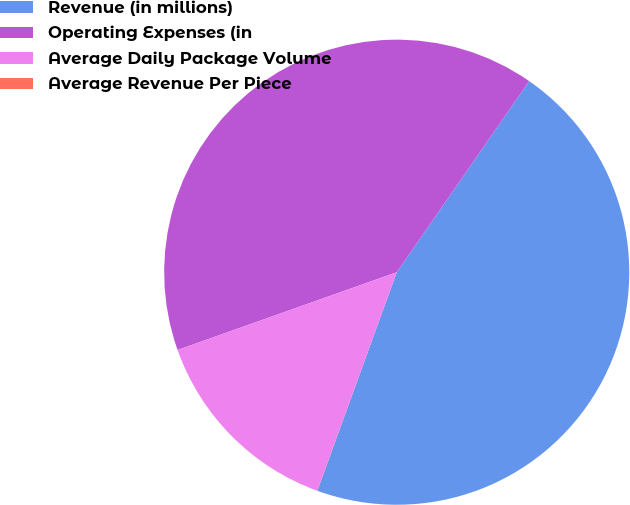Convert chart to OTSL. <chart><loc_0><loc_0><loc_500><loc_500><pie_chart><fcel>Revenue (in millions)<fcel>Operating Expenses (in<fcel>Average Daily Package Volume<fcel>Average Revenue Per Piece<nl><fcel>45.9%<fcel>40.07%<fcel>14.02%<fcel>0.01%<nl></chart> 